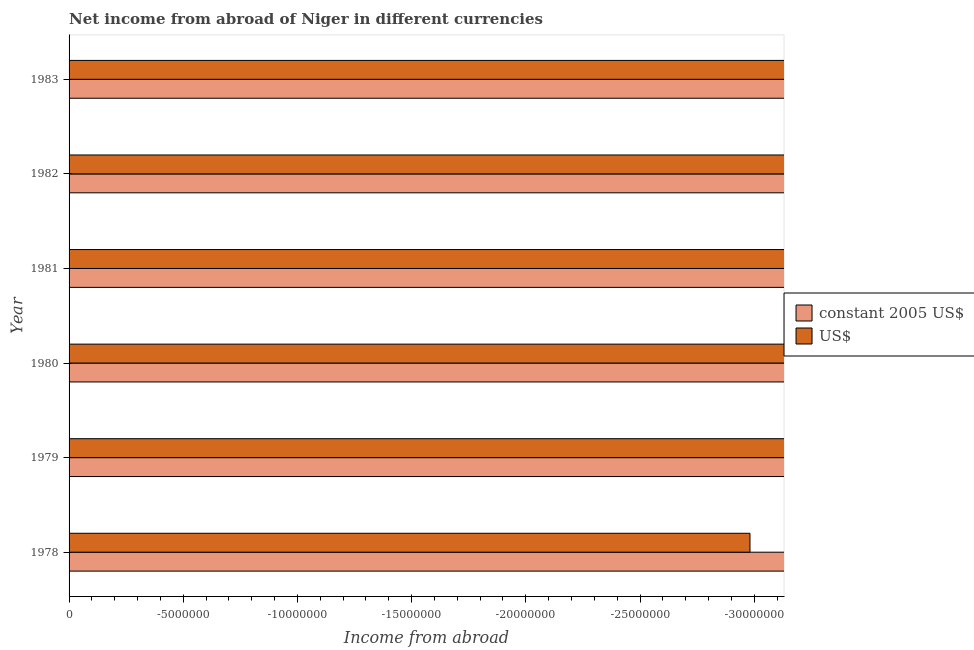How many different coloured bars are there?
Your answer should be compact. 0. Are the number of bars on each tick of the Y-axis equal?
Your answer should be very brief. Yes. How many bars are there on the 2nd tick from the top?
Make the answer very short. 0. In how many cases, is the number of bars for a given year not equal to the number of legend labels?
Ensure brevity in your answer.  6. Across all years, what is the minimum income from abroad in constant 2005 us$?
Offer a terse response. 0. What is the difference between the income from abroad in us$ in 1978 and the income from abroad in constant 2005 us$ in 1981?
Provide a short and direct response. 0. In how many years, is the income from abroad in us$ greater than -8000000 units?
Ensure brevity in your answer.  0. Are all the bars in the graph horizontal?
Your answer should be very brief. Yes. What is the difference between two consecutive major ticks on the X-axis?
Offer a terse response. 5.00e+06. Does the graph contain any zero values?
Offer a very short reply. Yes. Does the graph contain grids?
Provide a short and direct response. No. Where does the legend appear in the graph?
Offer a terse response. Center right. What is the title of the graph?
Offer a terse response. Net income from abroad of Niger in different currencies. What is the label or title of the X-axis?
Your response must be concise. Income from abroad. What is the Income from abroad of constant 2005 US$ in 1978?
Offer a very short reply. 0. What is the Income from abroad of constant 2005 US$ in 1979?
Your response must be concise. 0. What is the Income from abroad of US$ in 1980?
Your answer should be compact. 0. What is the Income from abroad in US$ in 1983?
Your answer should be compact. 0. What is the average Income from abroad in constant 2005 US$ per year?
Your response must be concise. 0. What is the average Income from abroad in US$ per year?
Keep it short and to the point. 0. 